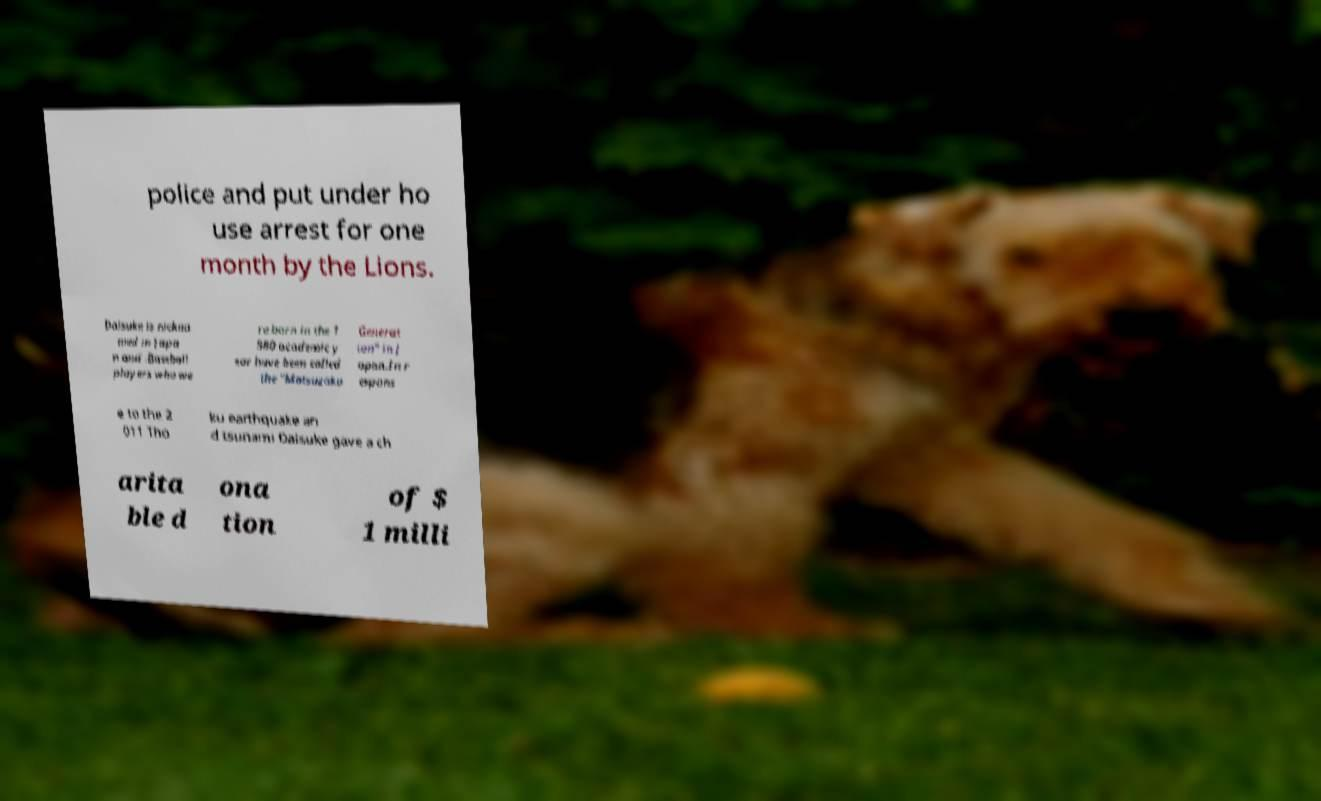Could you assist in decoding the text presented in this image and type it out clearly? police and put under ho use arrest for one month by the Lions. Daisuke is nickna med in Japa n and .Baseball players who we re born in the 1 980 academic y ear have been called the "Matsuzaka Generat ion" in J apan.In r espons e to the 2 011 Tho ku earthquake an d tsunami Daisuke gave a ch arita ble d ona tion of $ 1 milli 